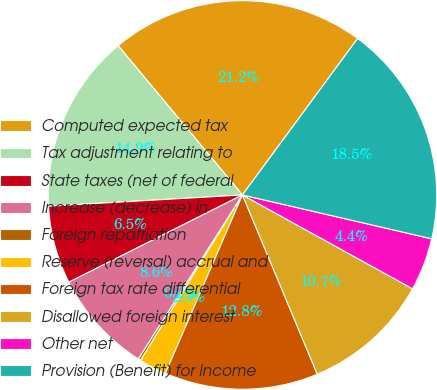Convert chart. <chart><loc_0><loc_0><loc_500><loc_500><pie_chart><fcel>Computed expected tax<fcel>Tax adjustment relating to<fcel>State taxes (net of federal<fcel>Increase (decrease) in<fcel>Foreign repatriation<fcel>Reserve (reversal) accrual and<fcel>Foreign tax rate differential<fcel>Disallowed foreign interest<fcel>Other net<fcel>Provision (Benefit) for Income<nl><fcel>21.15%<fcel>14.87%<fcel>6.49%<fcel>8.59%<fcel>0.21%<fcel>2.3%<fcel>12.78%<fcel>10.68%<fcel>4.4%<fcel>18.52%<nl></chart> 